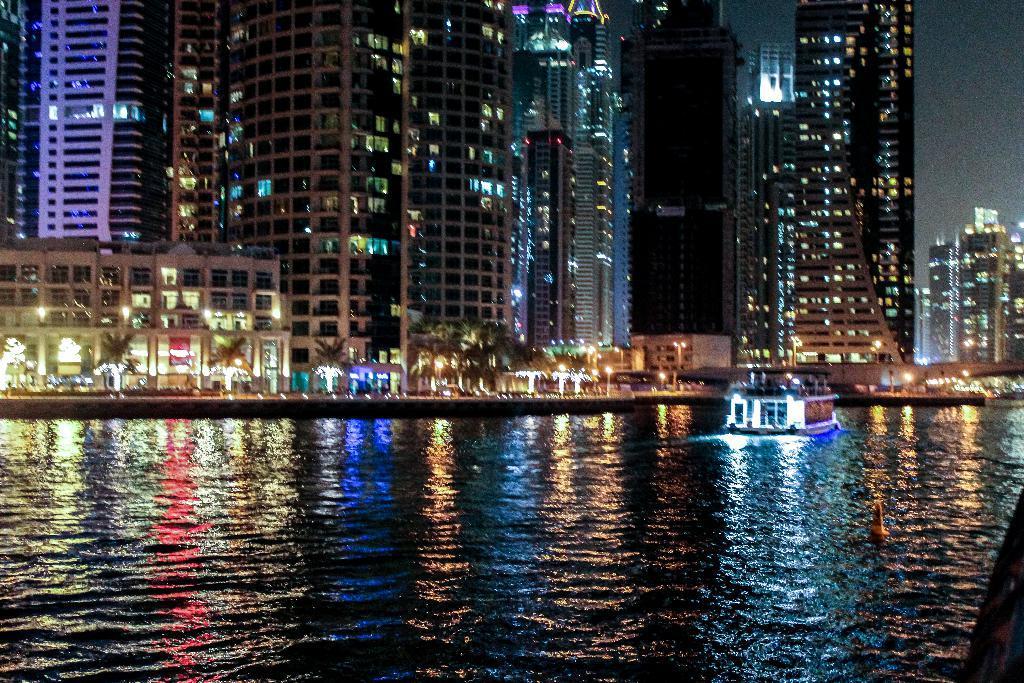Describe this image in one or two sentences. This picture is clicked outside the city. At the bottom, we see water and this water might be in the lake. In the middle, we see a boat sailing on the water. There are buildings, trees, street lights and the poles in the background. In the right top, we see the sky. This picture might be clicked in the dark. 